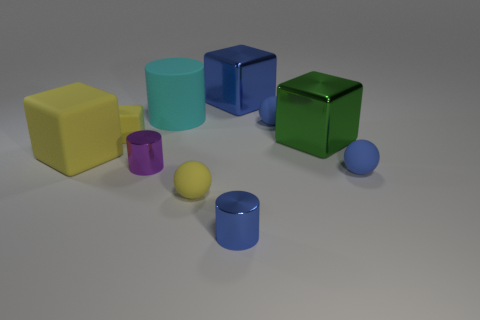Subtract all blocks. How many objects are left? 6 Add 5 tiny blue metal cylinders. How many tiny blue metal cylinders exist? 6 Subtract 0 cyan balls. How many objects are left? 10 Subtract all large cyan cylinders. Subtract all tiny blue metallic balls. How many objects are left? 9 Add 7 yellow spheres. How many yellow spheres are left? 8 